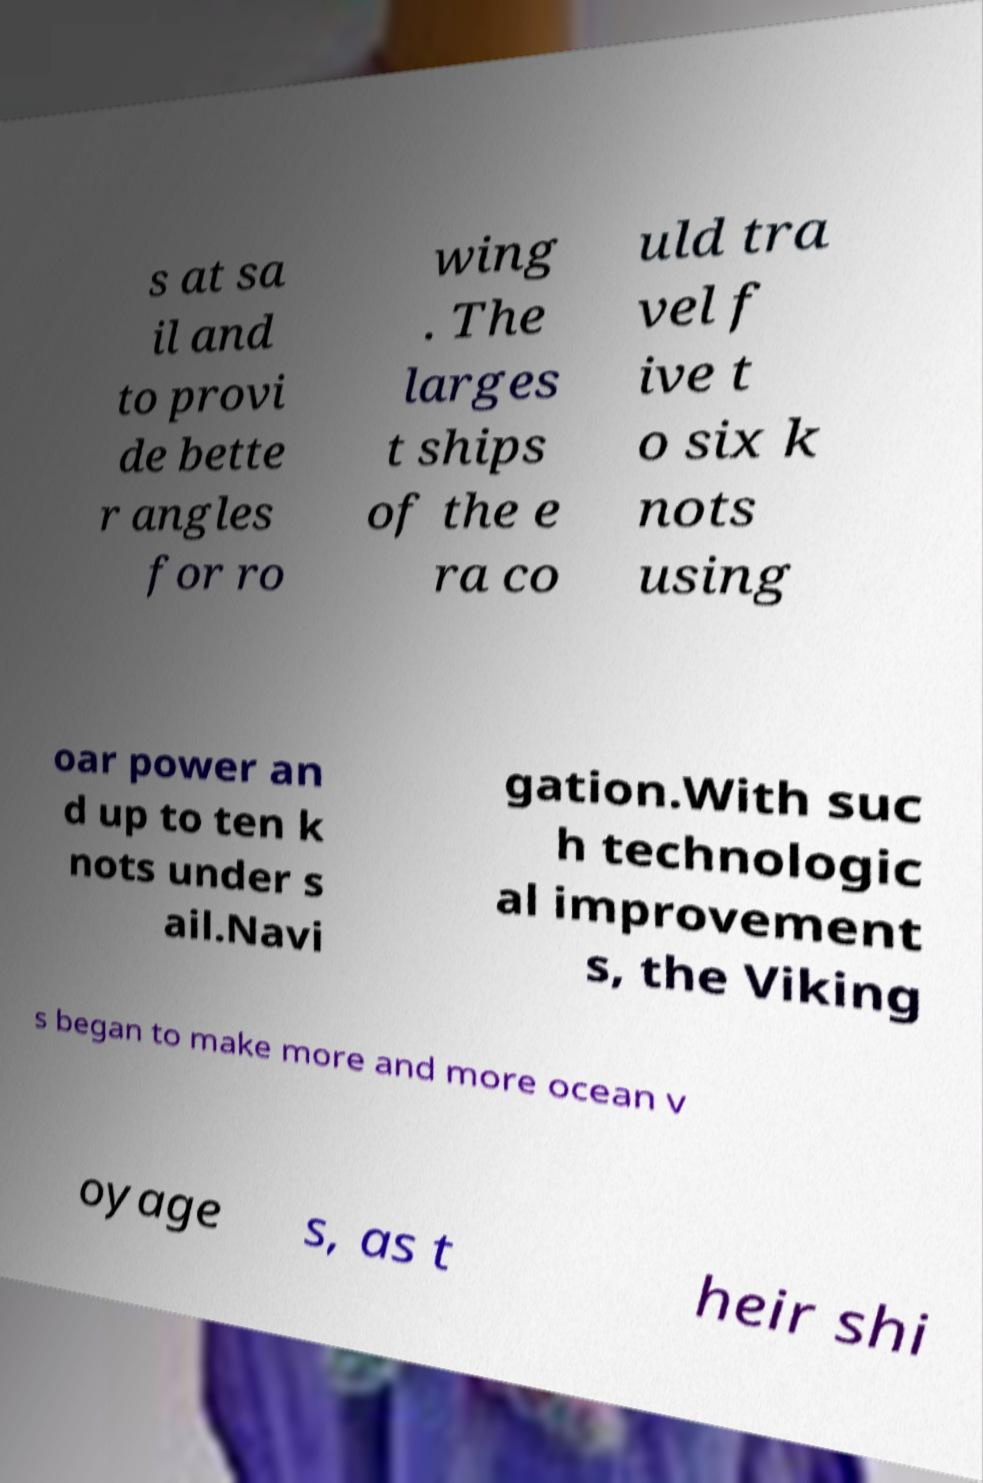What messages or text are displayed in this image? I need them in a readable, typed format. s at sa il and to provi de bette r angles for ro wing . The larges t ships of the e ra co uld tra vel f ive t o six k nots using oar power an d up to ten k nots under s ail.Navi gation.With suc h technologic al improvement s, the Viking s began to make more and more ocean v oyage s, as t heir shi 